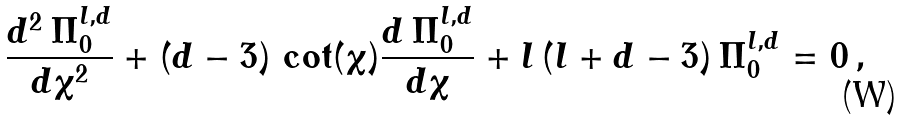<formula> <loc_0><loc_0><loc_500><loc_500>\frac { d ^ { 2 } \, \Pi ^ { l , d } _ { 0 } } { d \chi ^ { 2 } } + ( d - 3 ) \, \cot ( \chi ) \frac { d \, \Pi ^ { l , d } _ { 0 } } { d \chi } + l \, ( l + d - 3 ) \, \Pi ^ { l , d } _ { 0 } = 0 \, ,</formula> 